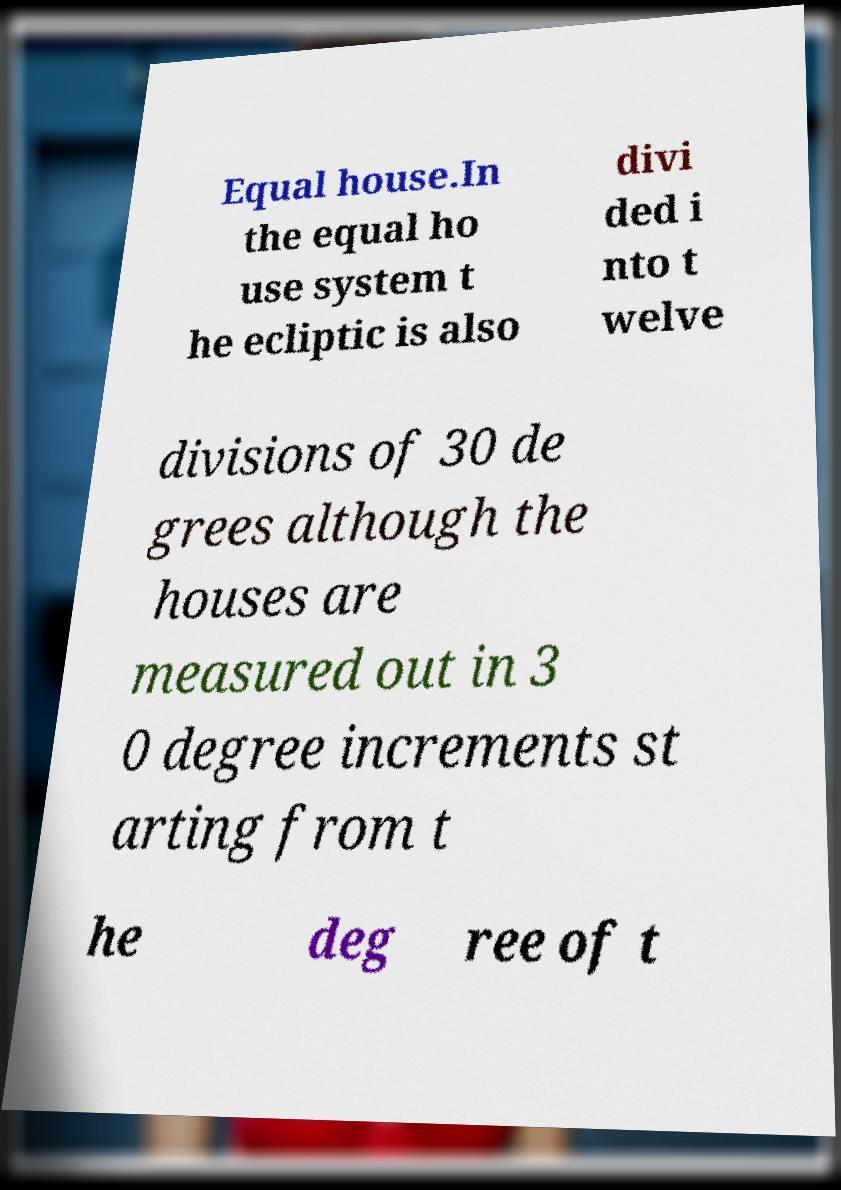Please read and relay the text visible in this image. What does it say? Equal house.In the equal ho use system t he ecliptic is also divi ded i nto t welve divisions of 30 de grees although the houses are measured out in 3 0 degree increments st arting from t he deg ree of t 